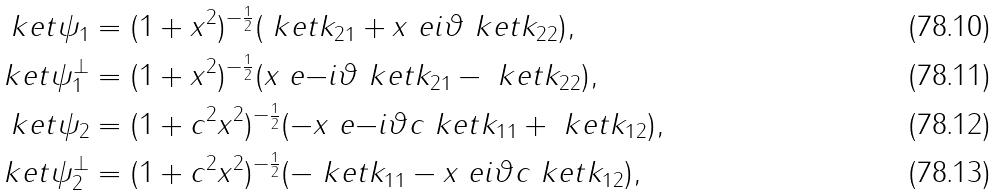Convert formula to latex. <formula><loc_0><loc_0><loc_500><loc_500>\ k e t { \psi _ { 1 } } & = ( 1 + x ^ { 2 } ) ^ { - \frac { 1 } { 2 } } ( \ k e t { k _ { 2 1 } } + x \ e { i \vartheta } \ k e t { k _ { 2 2 } } ) , \\ \ k e t { \psi _ { 1 } ^ { \perp } } & = ( 1 + x ^ { 2 } ) ^ { - \frac { 1 } { 2 } } ( x \ e { - i \vartheta } \ k e t { k _ { 2 1 } } - \ k e t { k _ { 2 2 } } ) , \\ \ k e t { \psi _ { 2 } } & = ( 1 + c ^ { 2 } x ^ { 2 } ) ^ { - \frac { 1 } { 2 } } ( - x \ e { - i \vartheta } c \ k e t { k _ { 1 1 } } + \ k e t { k _ { 1 2 } } ) , \\ \ k e t { \psi _ { 2 } ^ { \perp } } & = ( 1 + c ^ { 2 } x ^ { 2 } ) ^ { - \frac { 1 } { 2 } } ( - \ k e t { k _ { 1 1 } } - x \ e { i \vartheta } c \ k e t { k _ { 1 2 } } ) ,</formula> 